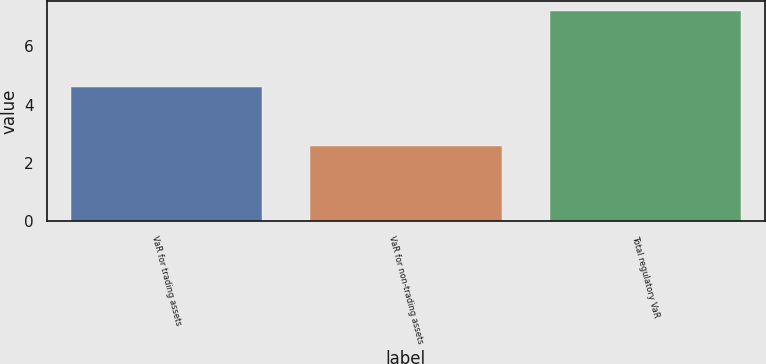Convert chart to OTSL. <chart><loc_0><loc_0><loc_500><loc_500><bar_chart><fcel>VaR for trading assets<fcel>VaR for non-trading assets<fcel>Total regulatory VaR<nl><fcel>4.6<fcel>2.6<fcel>7.2<nl></chart> 